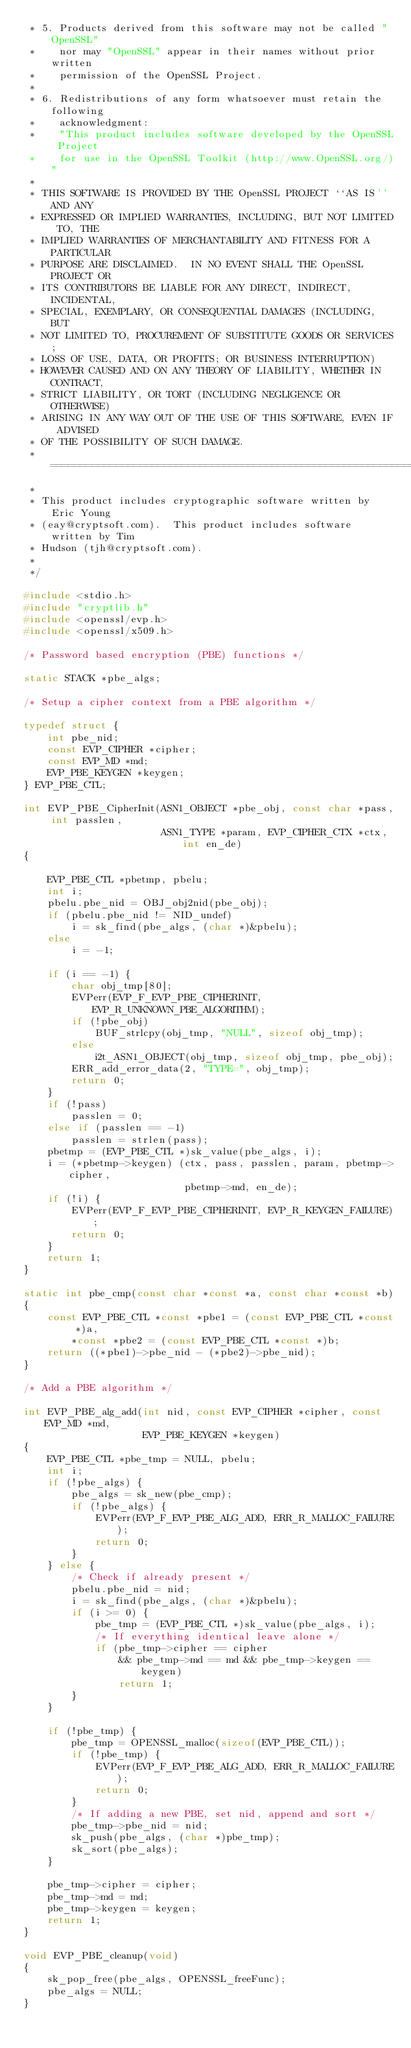Convert code to text. <code><loc_0><loc_0><loc_500><loc_500><_C_> * 5. Products derived from this software may not be called "OpenSSL"
 *    nor may "OpenSSL" appear in their names without prior written
 *    permission of the OpenSSL Project.
 *
 * 6. Redistributions of any form whatsoever must retain the following
 *    acknowledgment:
 *    "This product includes software developed by the OpenSSL Project
 *    for use in the OpenSSL Toolkit (http://www.OpenSSL.org/)"
 *
 * THIS SOFTWARE IS PROVIDED BY THE OpenSSL PROJECT ``AS IS'' AND ANY
 * EXPRESSED OR IMPLIED WARRANTIES, INCLUDING, BUT NOT LIMITED TO, THE
 * IMPLIED WARRANTIES OF MERCHANTABILITY AND FITNESS FOR A PARTICULAR
 * PURPOSE ARE DISCLAIMED.  IN NO EVENT SHALL THE OpenSSL PROJECT OR
 * ITS CONTRIBUTORS BE LIABLE FOR ANY DIRECT, INDIRECT, INCIDENTAL,
 * SPECIAL, EXEMPLARY, OR CONSEQUENTIAL DAMAGES (INCLUDING, BUT
 * NOT LIMITED TO, PROCUREMENT OF SUBSTITUTE GOODS OR SERVICES;
 * LOSS OF USE, DATA, OR PROFITS; OR BUSINESS INTERRUPTION)
 * HOWEVER CAUSED AND ON ANY THEORY OF LIABILITY, WHETHER IN CONTRACT,
 * STRICT LIABILITY, OR TORT (INCLUDING NEGLIGENCE OR OTHERWISE)
 * ARISING IN ANY WAY OUT OF THE USE OF THIS SOFTWARE, EVEN IF ADVISED
 * OF THE POSSIBILITY OF SUCH DAMAGE.
 * ====================================================================
 *
 * This product includes cryptographic software written by Eric Young
 * (eay@cryptsoft.com).  This product includes software written by Tim
 * Hudson (tjh@cryptsoft.com).
 *
 */

#include <stdio.h>
#include "cryptlib.h"
#include <openssl/evp.h>
#include <openssl/x509.h>

/* Password based encryption (PBE) functions */

static STACK *pbe_algs;

/* Setup a cipher context from a PBE algorithm */

typedef struct {
    int pbe_nid;
    const EVP_CIPHER *cipher;
    const EVP_MD *md;
    EVP_PBE_KEYGEN *keygen;
} EVP_PBE_CTL;

int EVP_PBE_CipherInit(ASN1_OBJECT *pbe_obj, const char *pass, int passlen,
                       ASN1_TYPE *param, EVP_CIPHER_CTX *ctx, int en_de)
{

    EVP_PBE_CTL *pbetmp, pbelu;
    int i;
    pbelu.pbe_nid = OBJ_obj2nid(pbe_obj);
    if (pbelu.pbe_nid != NID_undef)
        i = sk_find(pbe_algs, (char *)&pbelu);
    else
        i = -1;

    if (i == -1) {
        char obj_tmp[80];
        EVPerr(EVP_F_EVP_PBE_CIPHERINIT, EVP_R_UNKNOWN_PBE_ALGORITHM);
        if (!pbe_obj)
            BUF_strlcpy(obj_tmp, "NULL", sizeof obj_tmp);
        else
            i2t_ASN1_OBJECT(obj_tmp, sizeof obj_tmp, pbe_obj);
        ERR_add_error_data(2, "TYPE=", obj_tmp);
        return 0;
    }
    if (!pass)
        passlen = 0;
    else if (passlen == -1)
        passlen = strlen(pass);
    pbetmp = (EVP_PBE_CTL *)sk_value(pbe_algs, i);
    i = (*pbetmp->keygen) (ctx, pass, passlen, param, pbetmp->cipher,
                           pbetmp->md, en_de);
    if (!i) {
        EVPerr(EVP_F_EVP_PBE_CIPHERINIT, EVP_R_KEYGEN_FAILURE);
        return 0;
    }
    return 1;
}

static int pbe_cmp(const char *const *a, const char *const *b)
{
    const EVP_PBE_CTL *const *pbe1 = (const EVP_PBE_CTL *const *)a,
        *const *pbe2 = (const EVP_PBE_CTL *const *)b;
    return ((*pbe1)->pbe_nid - (*pbe2)->pbe_nid);
}

/* Add a PBE algorithm */

int EVP_PBE_alg_add(int nid, const EVP_CIPHER *cipher, const EVP_MD *md,
                    EVP_PBE_KEYGEN *keygen)
{
    EVP_PBE_CTL *pbe_tmp = NULL, pbelu;
    int i;
    if (!pbe_algs) {
        pbe_algs = sk_new(pbe_cmp);
        if (!pbe_algs) {
            EVPerr(EVP_F_EVP_PBE_ALG_ADD, ERR_R_MALLOC_FAILURE);
            return 0;
        }
    } else {
        /* Check if already present */
        pbelu.pbe_nid = nid;
        i = sk_find(pbe_algs, (char *)&pbelu);
        if (i >= 0) {
            pbe_tmp = (EVP_PBE_CTL *)sk_value(pbe_algs, i);
            /* If everything identical leave alone */
            if (pbe_tmp->cipher == cipher
                && pbe_tmp->md == md && pbe_tmp->keygen == keygen)
                return 1;
        }
    }

    if (!pbe_tmp) {
        pbe_tmp = OPENSSL_malloc(sizeof(EVP_PBE_CTL));
        if (!pbe_tmp) {
            EVPerr(EVP_F_EVP_PBE_ALG_ADD, ERR_R_MALLOC_FAILURE);
            return 0;
        }
        /* If adding a new PBE, set nid, append and sort */
        pbe_tmp->pbe_nid = nid;
        sk_push(pbe_algs, (char *)pbe_tmp);
        sk_sort(pbe_algs);
    }

    pbe_tmp->cipher = cipher;
    pbe_tmp->md = md;
    pbe_tmp->keygen = keygen;
    return 1;
}

void EVP_PBE_cleanup(void)
{
    sk_pop_free(pbe_algs, OPENSSL_freeFunc);
    pbe_algs = NULL;
}
</code> 